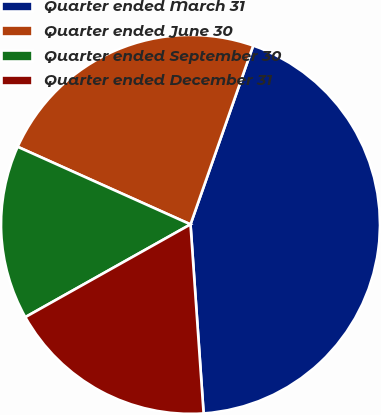Convert chart. <chart><loc_0><loc_0><loc_500><loc_500><pie_chart><fcel>Quarter ended March 31<fcel>Quarter ended June 30<fcel>Quarter ended September 30<fcel>Quarter ended December 31<nl><fcel>43.53%<fcel>23.65%<fcel>14.86%<fcel>17.96%<nl></chart> 